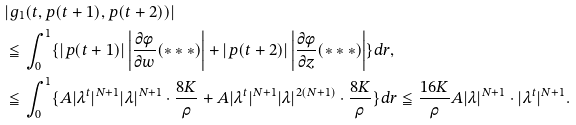<formula> <loc_0><loc_0><loc_500><loc_500>& | g _ { 1 } ( t , p ( t + 1 ) , p ( t + 2 ) ) | \\ & \leqq \int ^ { 1 } _ { 0 } \{ | p ( t + 1 ) | \left | \frac { \partial \phi } { \partial w } ( * * * ) \right | + | p ( t + 2 ) | \left | \frac { \partial \phi } { \partial z } ( * * * ) \right | \} d r , \\ & \leqq \int _ { 0 } ^ { 1 } \{ A | \lambda ^ { t } | ^ { N + 1 } | \lambda | ^ { N + 1 } \cdot \frac { 8 K } { \rho } + A | \lambda ^ { t } | ^ { N + 1 } | \lambda | ^ { 2 ( N + 1 ) } \cdot \frac { 8 K } { \rho } \} d r \leqq \frac { 1 6 K } { \rho } A | \lambda | ^ { N + 1 } \cdot | \lambda ^ { t } | ^ { N + 1 } .</formula> 